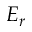<formula> <loc_0><loc_0><loc_500><loc_500>E _ { r }</formula> 